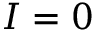Convert formula to latex. <formula><loc_0><loc_0><loc_500><loc_500>I = 0</formula> 